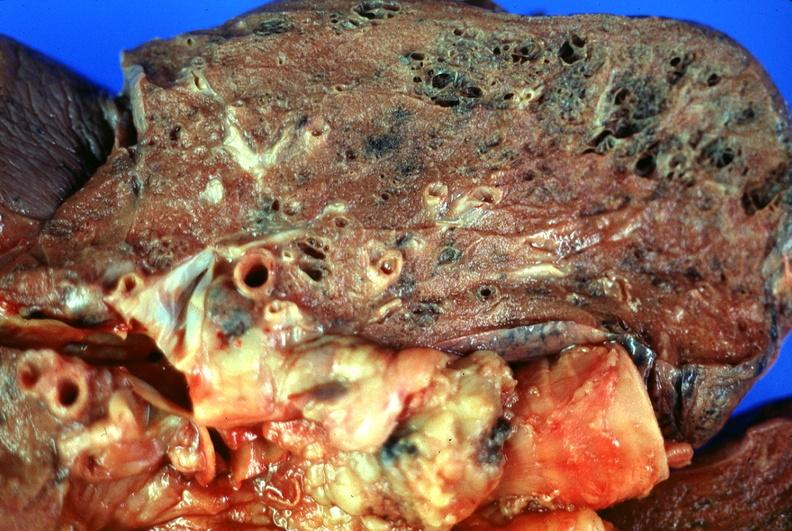s respiratory present?
Answer the question using a single word or phrase. Yes 